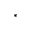<formula> <loc_0><loc_0><loc_500><loc_500>^ { * }</formula> 